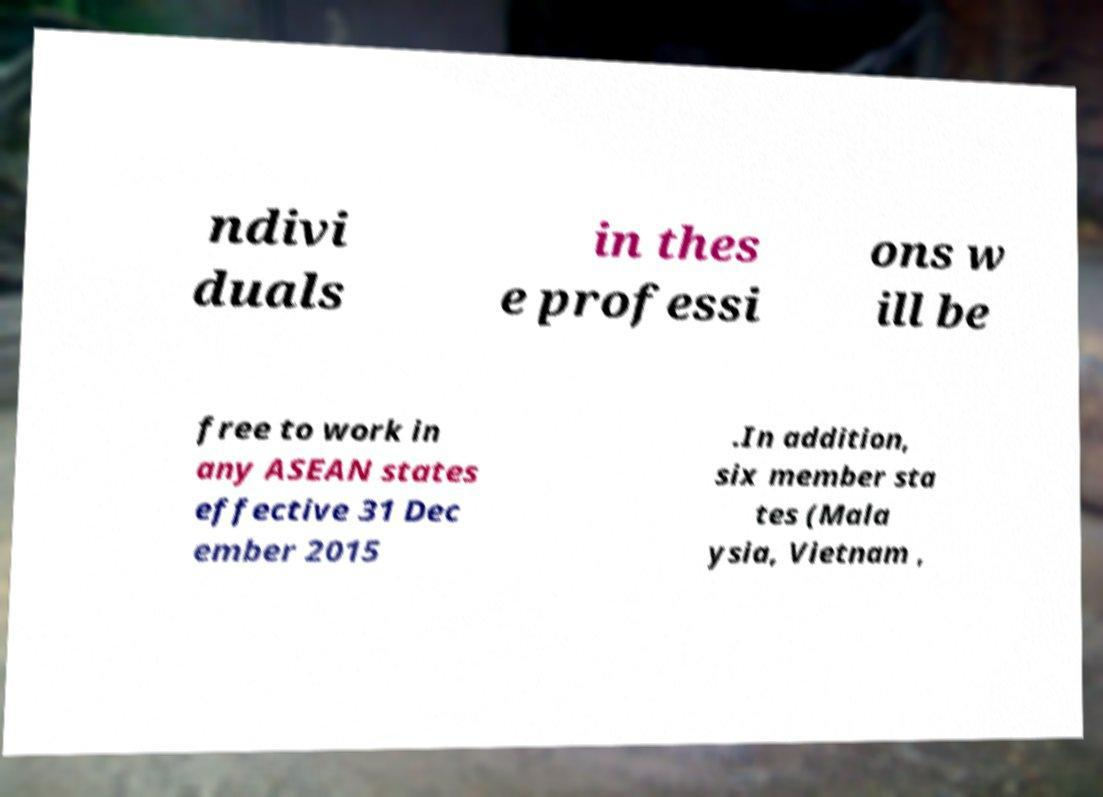For documentation purposes, I need the text within this image transcribed. Could you provide that? ndivi duals in thes e professi ons w ill be free to work in any ASEAN states effective 31 Dec ember 2015 .In addition, six member sta tes (Mala ysia, Vietnam , 